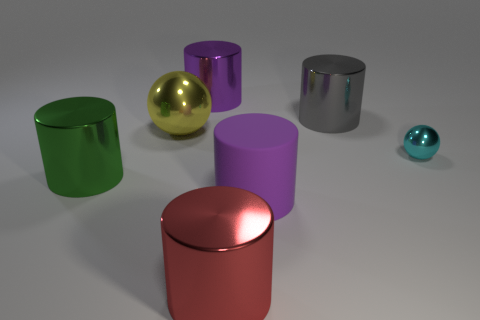The matte thing is what color?
Make the answer very short. Purple. What size is the purple thing behind the small cyan shiny thing?
Provide a succinct answer. Large. There is a shiny sphere left of the purple cylinder in front of the big yellow shiny ball; what number of large red metal things are behind it?
Keep it short and to the point. 0. There is a sphere behind the metal sphere that is to the right of the purple metallic cylinder; what color is it?
Give a very brief answer. Yellow. Are there any purple rubber cylinders of the same size as the green metal object?
Your answer should be very brief. Yes. There is a large purple thing behind the small cyan shiny thing to the right of the purple cylinder behind the large gray metal object; what is it made of?
Provide a succinct answer. Metal. How many small metallic balls are in front of the sphere in front of the large yellow thing?
Provide a short and direct response. 0. Is the size of the sphere on the left side of the purple matte thing the same as the rubber object?
Ensure brevity in your answer.  Yes. What number of other large purple objects are the same shape as the purple rubber thing?
Provide a succinct answer. 1. What is the shape of the tiny cyan metallic thing?
Offer a very short reply. Sphere. 